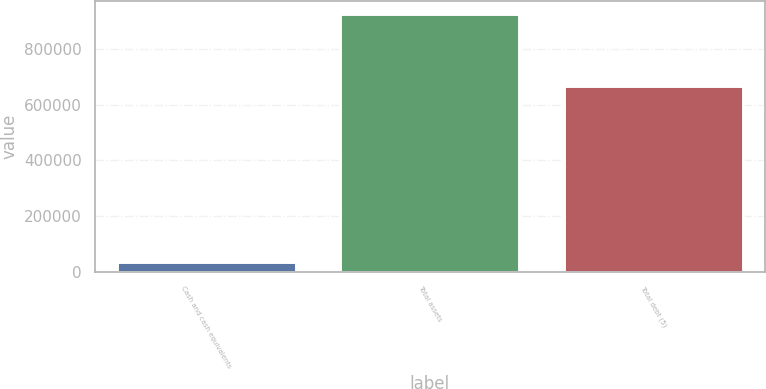Convert chart to OTSL. <chart><loc_0><loc_0><loc_500><loc_500><bar_chart><fcel>Cash and cash equivalents<fcel>Total assets<fcel>Total debt (5)<nl><fcel>33185<fcel>928877<fcel>669754<nl></chart> 